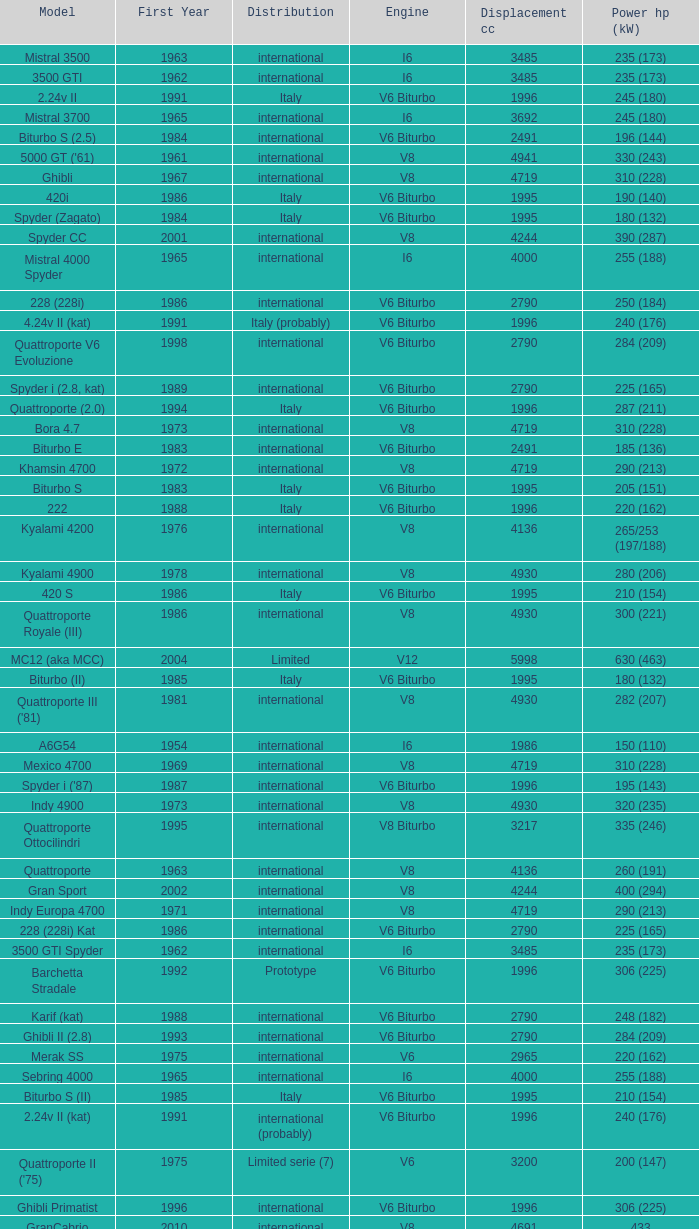Parse the full table. {'header': ['Model', 'First Year', 'Distribution', 'Engine', 'Displacement cc', 'Power hp (kW)'], 'rows': [['Mistral 3500', '1963', 'international', 'I6', '3485', '235 (173)'], ['3500 GTI', '1962', 'international', 'I6', '3485', '235 (173)'], ['2.24v II', '1991', 'Italy', 'V6 Biturbo', '1996', '245 (180)'], ['Mistral 3700', '1965', 'international', 'I6', '3692', '245 (180)'], ['Biturbo S (2.5)', '1984', 'international', 'V6 Biturbo', '2491', '196 (144)'], ["5000 GT ('61)", '1961', 'international', 'V8', '4941', '330 (243)'], ['Ghibli', '1967', 'international', 'V8', '4719', '310 (228)'], ['420i', '1986', 'Italy', 'V6 Biturbo', '1995', '190 (140)'], ['Spyder (Zagato)', '1984', 'Italy', 'V6 Biturbo', '1995', '180 (132)'], ['Spyder CC', '2001', 'international', 'V8', '4244', '390 (287)'], ['Mistral 4000 Spyder', '1965', 'international', 'I6', '4000', '255 (188)'], ['228 (228i)', '1986', 'international', 'V6 Biturbo', '2790', '250 (184)'], ['4.24v II (kat)', '1991', 'Italy (probably)', 'V6 Biturbo', '1996', '240 (176)'], ['Quattroporte V6 Evoluzione', '1998', 'international', 'V6 Biturbo', '2790', '284 (209)'], ['Spyder i (2.8, kat)', '1989', 'international', 'V6 Biturbo', '2790', '225 (165)'], ['Quattroporte (2.0)', '1994', 'Italy', 'V6 Biturbo', '1996', '287 (211)'], ['Bora 4.7', '1973', 'international', 'V8', '4719', '310 (228)'], ['Biturbo E', '1983', 'international', 'V6 Biturbo', '2491', '185 (136)'], ['Khamsin 4700', '1972', 'international', 'V8', '4719', '290 (213)'], ['Biturbo S', '1983', 'Italy', 'V6 Biturbo', '1995', '205 (151)'], ['222', '1988', 'Italy', 'V6 Biturbo', '1996', '220 (162)'], ['Kyalami 4200', '1976', 'international', 'V8', '4136', '265/253 (197/188)'], ['Kyalami 4900', '1978', 'international', 'V8', '4930', '280 (206)'], ['420 S', '1986', 'Italy', 'V6 Biturbo', '1995', '210 (154)'], ['Quattroporte Royale (III)', '1986', 'international', 'V8', '4930', '300 (221)'], ['MC12 (aka MCC)', '2004', 'Limited', 'V12', '5998', '630 (463)'], ['Biturbo (II)', '1985', 'Italy', 'V6 Biturbo', '1995', '180 (132)'], ["Quattroporte III ('81)", '1981', 'international', 'V8', '4930', '282 (207)'], ['A6G54', '1954', 'international', 'I6', '1986', '150 (110)'], ['Mexico 4700', '1969', 'international', 'V8', '4719', '310 (228)'], ["Spyder i ('87)", '1987', 'international', 'V6 Biturbo', '1996', '195 (143)'], ['Indy 4900', '1973', 'international', 'V8', '4930', '320 (235)'], ['Quattroporte Ottocilindri', '1995', 'international', 'V8 Biturbo', '3217', '335 (246)'], ['Quattroporte', '1963', 'international', 'V8', '4136', '260 (191)'], ['Gran Sport', '2002', 'international', 'V8', '4244', '400 (294)'], ['Indy Europa 4700', '1971', 'international', 'V8', '4719', '290 (213)'], ['228 (228i) Kat', '1986', 'international', 'V6 Biturbo', '2790', '225 (165)'], ['3500 GTI Spyder', '1962', 'international', 'I6', '3485', '235 (173)'], ['Barchetta Stradale', '1992', 'Prototype', 'V6 Biturbo', '1996', '306 (225)'], ['Karif (kat)', '1988', 'international', 'V6 Biturbo', '2790', '248 (182)'], ['Ghibli II (2.8)', '1993', 'international', 'V6 Biturbo', '2790', '284 (209)'], ['Merak SS', '1975', 'international', 'V6', '2965', '220 (162)'], ['Sebring 4000', '1965', 'international', 'I6', '4000', '255 (188)'], ['Biturbo S (II)', '1985', 'Italy', 'V6 Biturbo', '1995', '210 (154)'], ['2.24v II (kat)', '1991', 'international (probably)', 'V6 Biturbo', '1996', '240 (176)'], ["Quattroporte II ('75)", '1975', 'Limited serie (7)', 'V6', '3200', '200 (147)'], ['Ghibli Primatist', '1996', 'international', 'V6 Biturbo', '1996', '306 (225)'], ['GranCabrio', '2010', 'international', 'V8', '4691', '433'], ['Barchetta Stradale 2.8', '1992', 'Single, Conversion', 'V6 Biturbo', '2790', '284 (209)'], ['Biturbo Si (2.5)', '1987', 'international', 'V6 Biturbo', '2491', '188 (138)'], ['Quattroporte (2.8)', '1994', 'international', 'V6 Biturbo', '2790', '284 (209)'], ['Spyder III (kat)', '1991', 'Italy', 'V6 Biturbo', '1996', '240 (176)'], ['Coupé CC', '2001', 'international', 'V8', '4244', '390 (287)'], ['Merak', '1973', 'international', 'V6', '2965', '190 (140)'], ['Biturbo E (II 2.5)', '1985', 'international', 'V6 Biturbo', '2491', '185 (136)'], ["Merak SS ('79)", '1979', 'international', 'V6', '2965', '208 (153)'], ['425i', '1987', 'international', 'V6 Biturbo', '2491', '188 (138)'], ['Biturbo Si', '1987', 'Italy', 'V6 Biturbo', '1995', '220 (162)'], ["Khamsin ('79)", '1979', 'international', 'V8', '4930', '280 (206)'], ['Biturbo i', '1986', 'Italy', 'V6 Biturbo', '1995', '185 (136)'], ['Ghibli Cup', '1995', 'international', 'V6 Biturbo', '1996', '330 (243)'], ['Racing', '1991', 'Italy', 'V6 Biturbo', '1996', '283 (208)'], ['Spyder i (2.5)', '1988', 'international', 'V6 Biturbo', '2491', '188 (138)'], ['222 SE', '1990', 'international', 'V6 Biturbo', '2790', '250 (184)'], ['222 SR', '1991', 'international', 'V6 Biturbo', '2790', '225 (165)'], ["A6G54 ('56)", '1956', 'international', 'I6', '1986', '160 (118)'], ['2.24V', '1988', 'Italy (probably)', 'V6 Biturbo', '1996', '245 (180)'], ['Mistral 4000', '1965', 'international', 'I6', '4000', '255 (188)'], ["Quattroporte ('66)", '1966', 'international', 'V8', '4719', '290 (213)'], ['Bora 4.9', '1975', 'international', 'V8', '4930', '330 (243)'], ['4.18v', '1990', 'Italy', 'V6 Biturbo', '1995', '220 (162)'], ['420', '1985', 'Italy', 'V6 Biturbo', '1995', '180 (132)'], ['Spyder III', '1991', 'Italy', 'V6 Biturbo', '1996', '245 (180)'], ['Spyder i (2.8)', '1989', 'international', 'V6 Biturbo', '2790', '250 (184)'], ['Karif', '1988', 'international', 'V6 Biturbo', '2790', '285 (210)'], ['4.24v', '1990', 'Italy (probably)', 'V6 Biturbo', '1996', '245 (180)'], ["Spyder i ('90)", '1989', 'Italy', 'V6 Biturbo', '1996', '220 (162)'], ['3500 GT Touring', '1957', 'international', 'I6', '3485', '220/230 (164/171)'], ['430 4v', '1991', 'international', 'V6 Biturbo', '2790', '279 (205)'], ['Karif (kat II)', '1988', 'international', 'V6 Biturbo', '2790', '225 (165)'], ['Shamal', '1990', 'international', 'V8 Biturbo', '3217', '326 (240)'], ['Ghibli II (2.0)', '1992', 'Italy', 'V6 Biturbo', '1996', '306 (225)'], ['222 SE (kat)', '1990', 'international', 'V6 Biturbo', '2790', '225 (165)'], ['Quattroporte II', '1974', 'pre-production (6)', 'V6', '2965', '190 (140)'], ['Bora 4.9 (US)', '1974', 'USA only', 'V8', '4930', '300 (221)'], ['Quattroporte V', '2004', 'international', 'V8', '4244', '400 (294)'], ['Coupé GT', '2001', 'international', 'V8', '4244', '390 (287)'], ['Indy Europa 4200', '1970', 'international', 'V8', '4136', '260 (191)'], ['430', '1987', 'international', 'V6 Biturbo', '2790', '225 (165)'], ['3200 GTA', '2000', 'international', 'V8 Biturbo', '3217', '368 (271)'], ['Mistral 3700 Spyder', '1965', 'international', 'I6', '3692', '245 (180)'], ['Spyder GT', '2001', 'international', 'V8', '4244', '390 (287)'], ['A6', '1946', 'international', 'I6', '1489', '65 (48)'], ['A6G', '1951', 'international', 'I6', '1954', '100 (74)'], ['Spyder III (2.8, kat)', '1991', 'international', 'V6 Biturbo', '2790', '225 (165)'], ['Khamsin 4900', '1972', 'international', 'V8', '4930', '320 (235)'], ['Quattroporte V8 Evoluzione', '1998', 'international', 'V8 Biturbo', '3217', '335 (246)'], ['Spyder (2.5)', '1984', 'international', 'V6 Biturbo', '2491', '192 (141)'], ['Mexico 4200', '1966', 'international', 'V8', '4136', '260 (191)'], ['Biturbo', '1981', 'Italy', 'V6 Biturbo', '1995', '180 (132)'], ['Merak 2000 GT', '1976', 'Italy', 'V6', '1999', '170/159 (126/118)'], ['3500 GT Spyder Vignale', '1959', 'international', 'I6', '3485', '220/230 (164/171)'], ['Ghibli Spyder', '1969', 'international', 'V8', '4719', '310 (228)'], ['Ghibli SS', '1970', 'international', 'V8', '4930', '335 (246)'], ['222 4v', '1988', 'international', 'V6 Biturbo', '2790', '279 (205)'], ['422', '1988', 'Italy', 'V6 Biturbo', '1996', '220 (162)'], ['3500 GTI Spyder Frua', '1964', 'international', 'I6', '3485', '235 (173)'], ['Sebring 3700', '1965', 'international', 'I6', '3692', '245 (180)'], ['3200 GT', '1998', 'international', 'V8 Biturbo', '3217', '370 (272)'], ['Spyder i', '1986', 'international', 'V6 Biturbo', '1996', '185 (136)'], ['GranTurismo', '2008', 'international', 'V8', '4244', '405'], ['Ghibli SS Spyder', '1970', 'international', 'V8', '4930', '335 (246)'], ['222 E', '1988', 'international', 'V6 Biturbo', '2790', '225 (165)'], ['4porte (Quattroporte III)', '1976', 'international', 'V8', '4136', '255 (188)'], ['425', '1983', 'international', 'V6 Biturbo', '2491', '200 (147)'], ['5000 GT', '1959', 'international', 'V8', '4941', '340 (250)']]} What is the lowest First Year, when Model is "Quattroporte (2.8)"? 1994.0. 